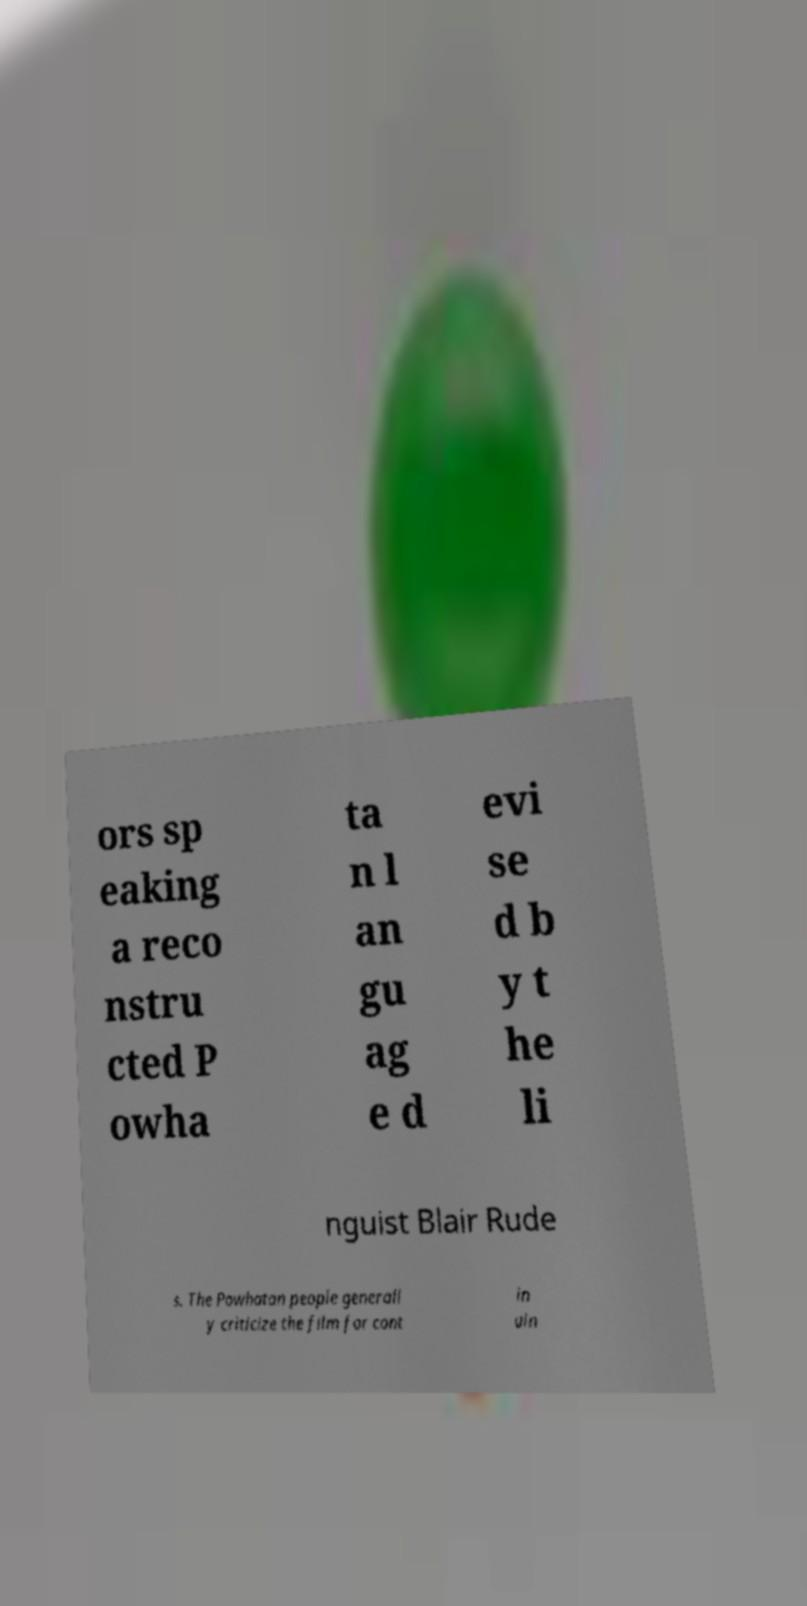Please read and relay the text visible in this image. What does it say? ors sp eaking a reco nstru cted P owha ta n l an gu ag e d evi se d b y t he li nguist Blair Rude s. The Powhatan people generall y criticize the film for cont in uin 